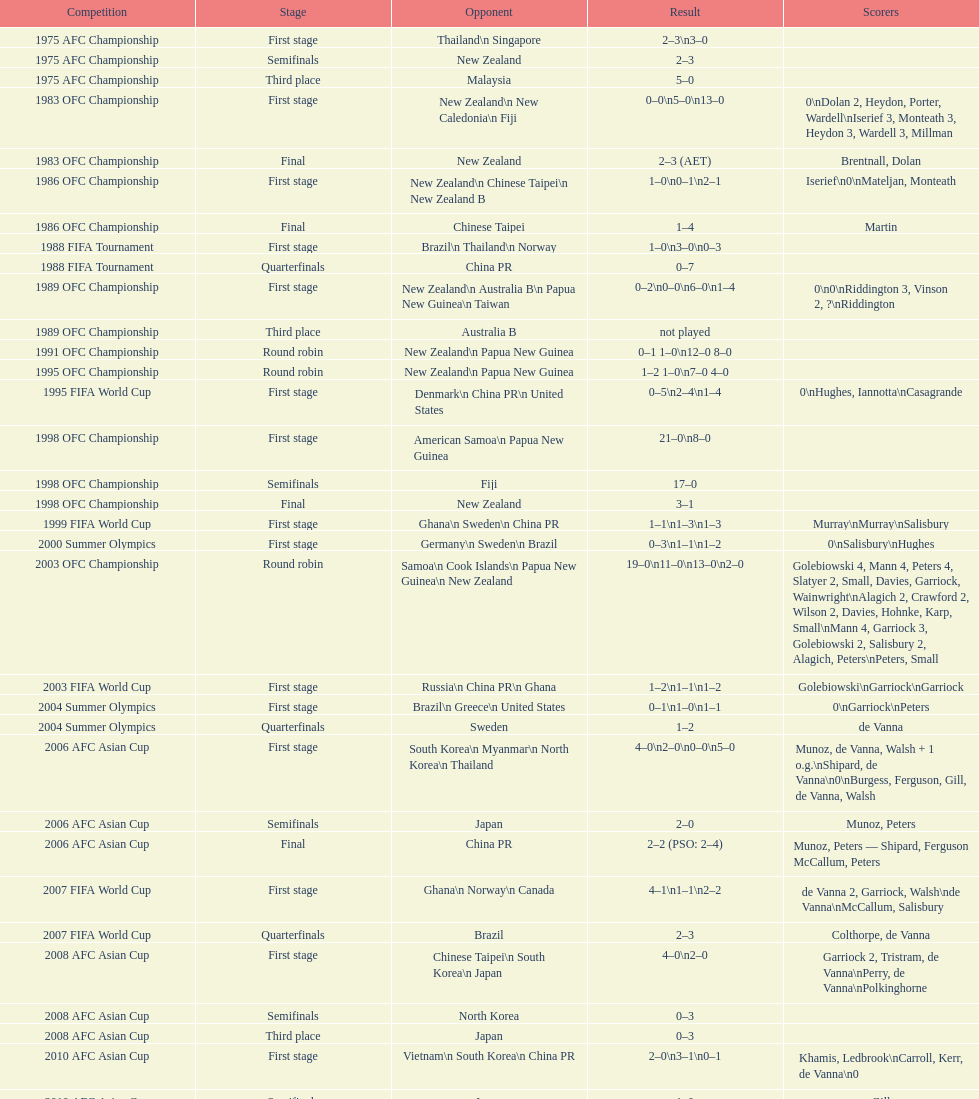What was the overall number of goals scored during the 1983 ofc championship? 18. 